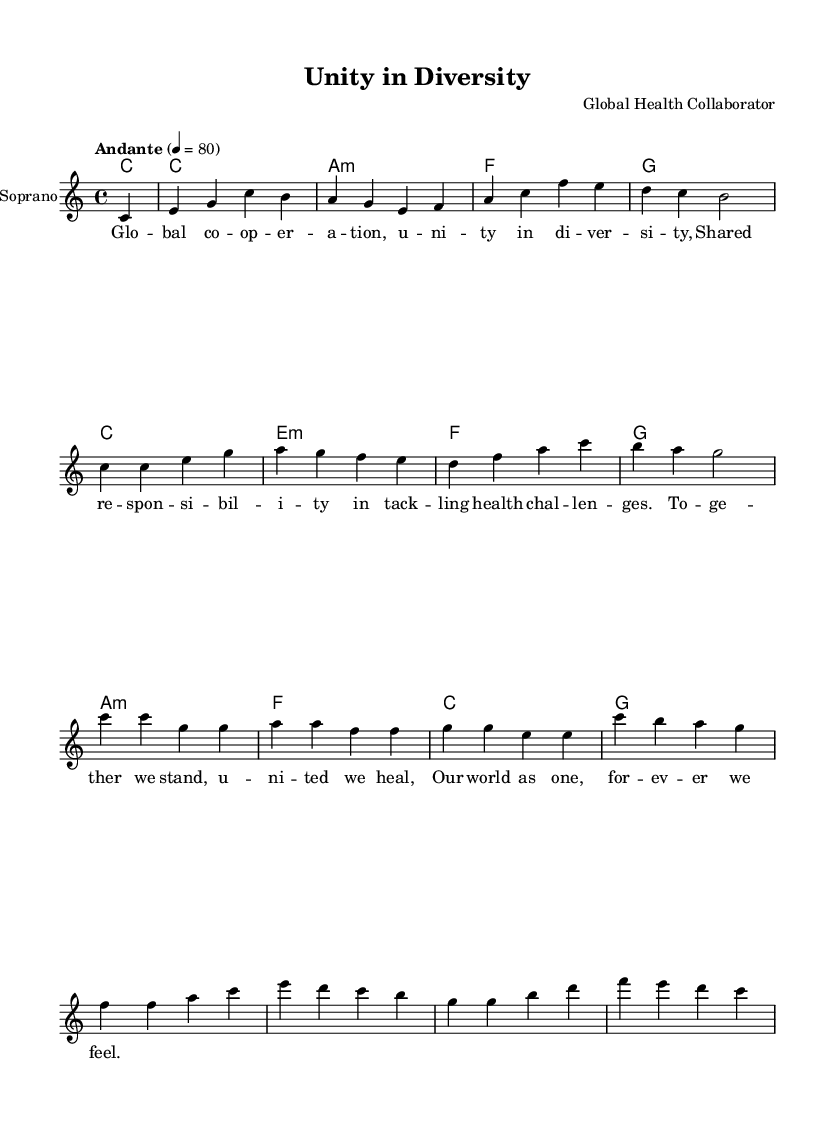What is the key signature of this music? The key signature is indicated as C major, which contains no sharps or flats.
Answer: C major What is the time signature of this composition? The time signature shown at the beginning of the score is 4/4, meaning there are four beats in each measure.
Answer: 4/4 What is the tempo marking for this piece? The tempo marking is indicated as "Andante," which suggests a moderately slow pace of movement.
Answer: Andante How many measures are in the soprano part? By counting the distinct segments separated by vertical lines, there are 16 measures in the soprano part.
Answer: 16 What is the first lyric sung by the soprano? The first lyric is located right above the first note and is "Global".
Answer: Global Describe the harmonic progression used in this piece. The harmonic progression starts with a C major chord, followed by a series of a minor, F, and G major chords, indicating a common progression in Western music.
Answer: C, a minor, F, G What theme does the lyrics of this opera convey? The lyrics focus on the theme of unity and cooperation in global health challenges, emphasizing collective responsibility and healing.
Answer: Unity and cooperation 